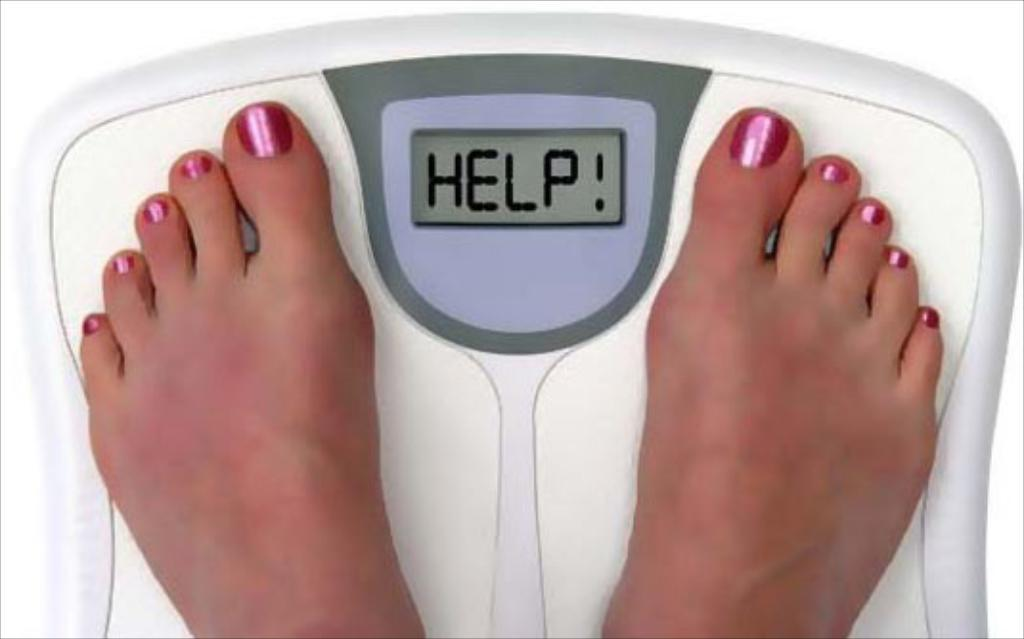What type of machine is in the image? There is a weight checking machine in the image. What can be seen on the screen of the machine? There is text visible on the screen of the machine. Can you describe any details about the person using the machine? A person's foot with nail polish is present in the image. What type of thunder can be heard in the background of the image? There is no thunder present in the image; it is a still image of a weight checking machine. 